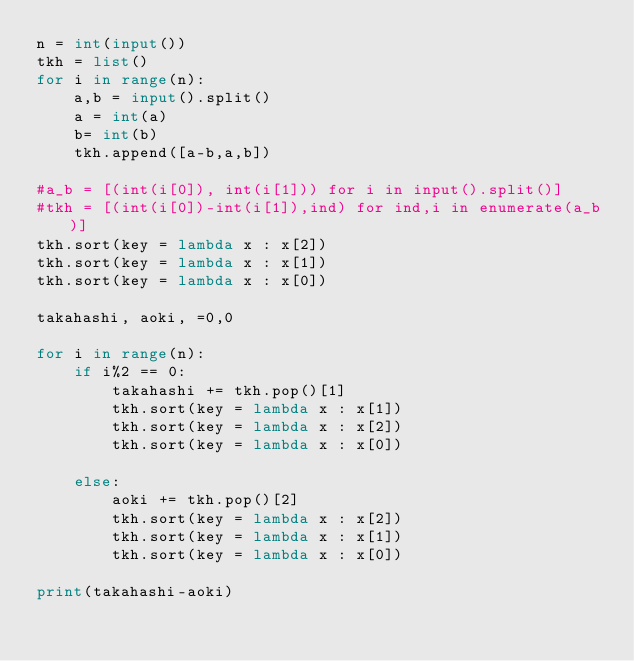Convert code to text. <code><loc_0><loc_0><loc_500><loc_500><_Python_>n = int(input())
tkh = list()
for i in range(n):
    a,b = input().split()
    a = int(a)
    b= int(b)
    tkh.append([a-b,a,b])

#a_b = [(int(i[0]), int(i[1])) for i in input().split()]
#tkh = [(int(i[0])-int(i[1]),ind) for ind,i in enumerate(a_b)]
tkh.sort(key = lambda x : x[2])
tkh.sort(key = lambda x : x[1])
tkh.sort(key = lambda x : x[0])

takahashi, aoki, =0,0

for i in range(n):
    if i%2 == 0:
        takahashi += tkh.pop()[1]
        tkh.sort(key = lambda x : x[1])
        tkh.sort(key = lambda x : x[2])
        tkh.sort(key = lambda x : x[0])

    else:
        aoki += tkh.pop()[2]
        tkh.sort(key = lambda x : x[2])
        tkh.sort(key = lambda x : x[1])
        tkh.sort(key = lambda x : x[0])

print(takahashi-aoki)</code> 